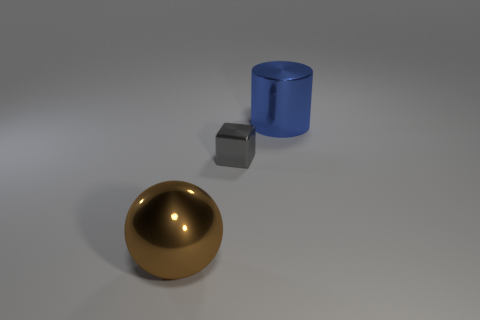Can you speculate on the purpose of these objects or the setting they are in? Without additional context, it's difficult to state the purpose of these objects definitively. They could be part of a simple 3D composition designed for visual or artistic purposes, a display for showcasing material renders, or even a test scene for lighting and reflection. The setting appears to be an abstract space with no discernible features other than a uniform grey surface. 